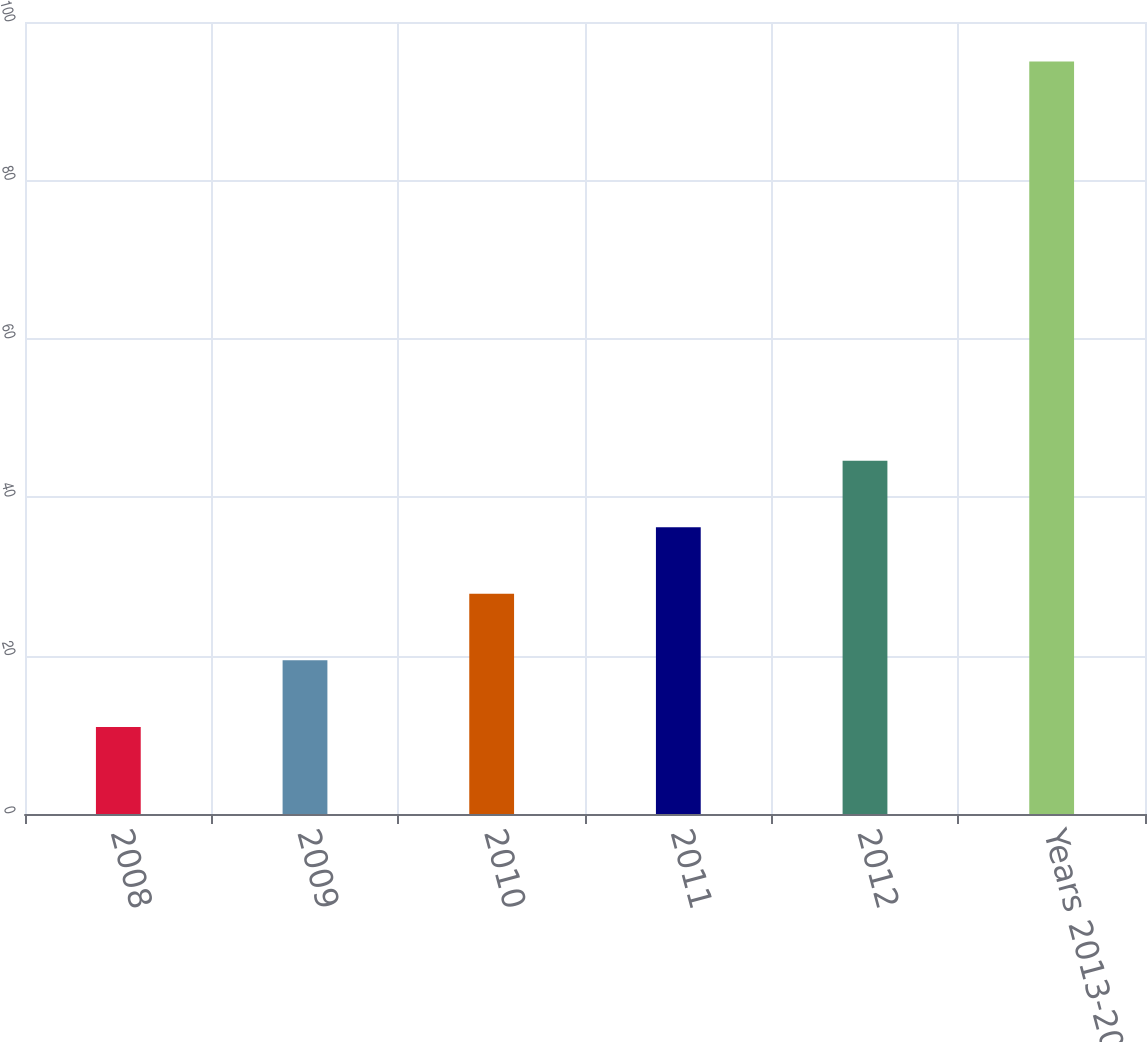<chart> <loc_0><loc_0><loc_500><loc_500><bar_chart><fcel>2008<fcel>2009<fcel>2010<fcel>2011<fcel>2012<fcel>Years 2013-2017<nl><fcel>11<fcel>19.4<fcel>27.8<fcel>36.2<fcel>44.6<fcel>95<nl></chart> 